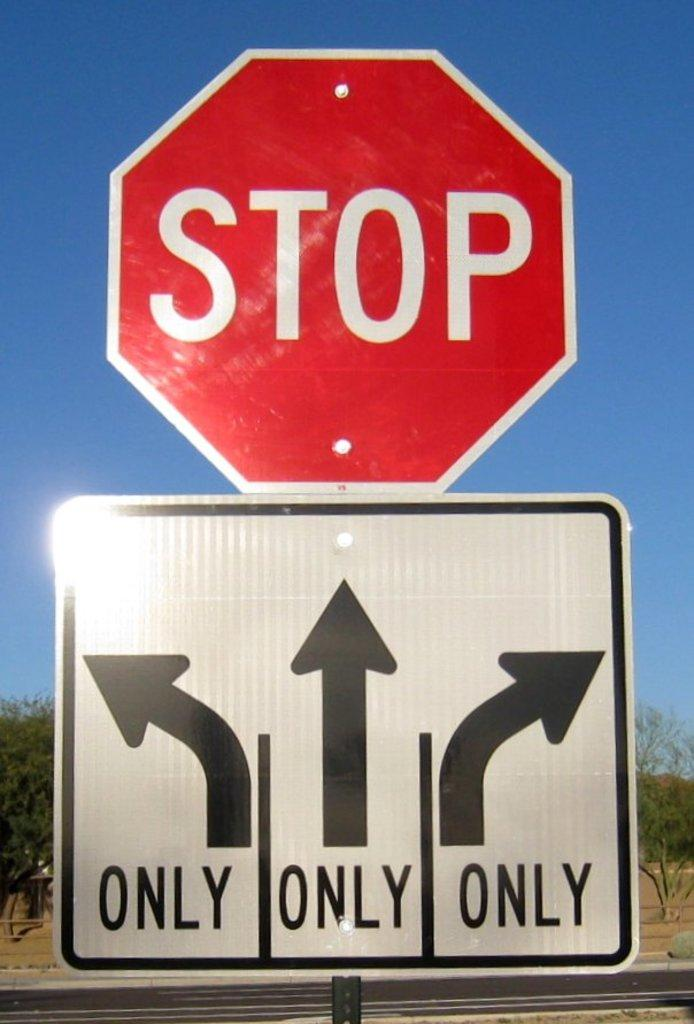What is the main object in the image? There is a sign board in the image. What is written or depicted on the sign board? There is text on the sign board. What can be seen in the background behind the sign board? There are trees visible behind the sign board. What type of pathway is present in the image? There is a road in the image. What is visible at the top of the image? The sky is visible at the top of the image. Where is the jail located in the image? There is no jail present in the image. What type of pan is being used to cook on the road in the image? There is no pan or cooking activity present in the image. 